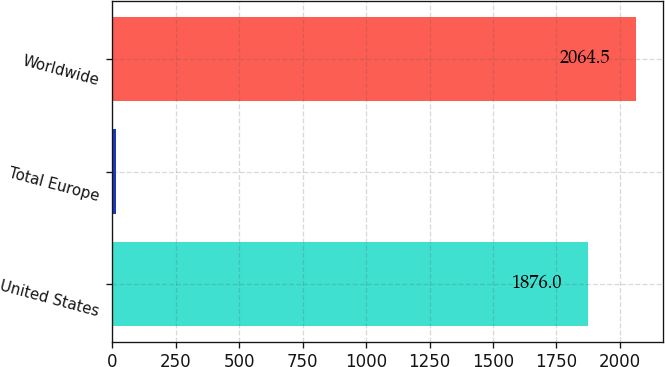Convert chart to OTSL. <chart><loc_0><loc_0><loc_500><loc_500><bar_chart><fcel>United States<fcel>Total Europe<fcel>Worldwide<nl><fcel>1876<fcel>16<fcel>2064.5<nl></chart> 